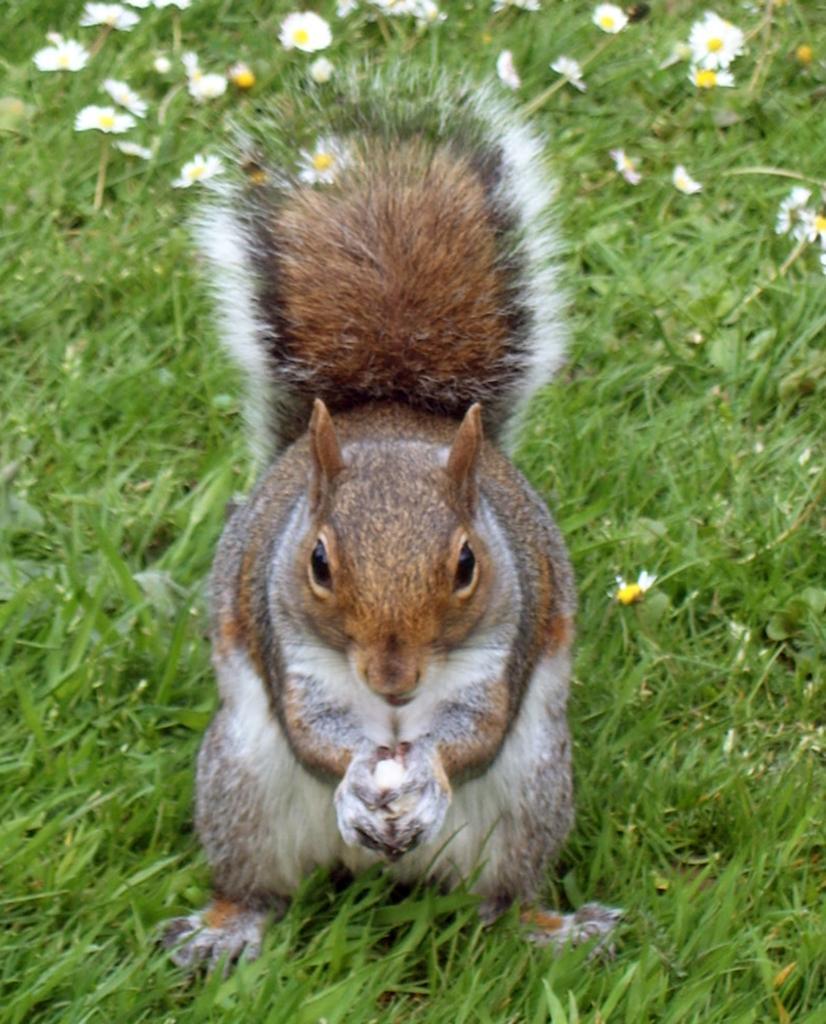Please provide a concise description of this image. In this image we can see the squirrel holding something in the hands. Here we can see the green grass and flowers. 